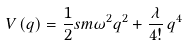Convert formula to latex. <formula><loc_0><loc_0><loc_500><loc_500>V \left ( q \right ) = \frac { 1 } { 2 } s m \omega ^ { 2 } q ^ { 2 } + \frac { \lambda } { 4 ! } \, q ^ { 4 }</formula> 